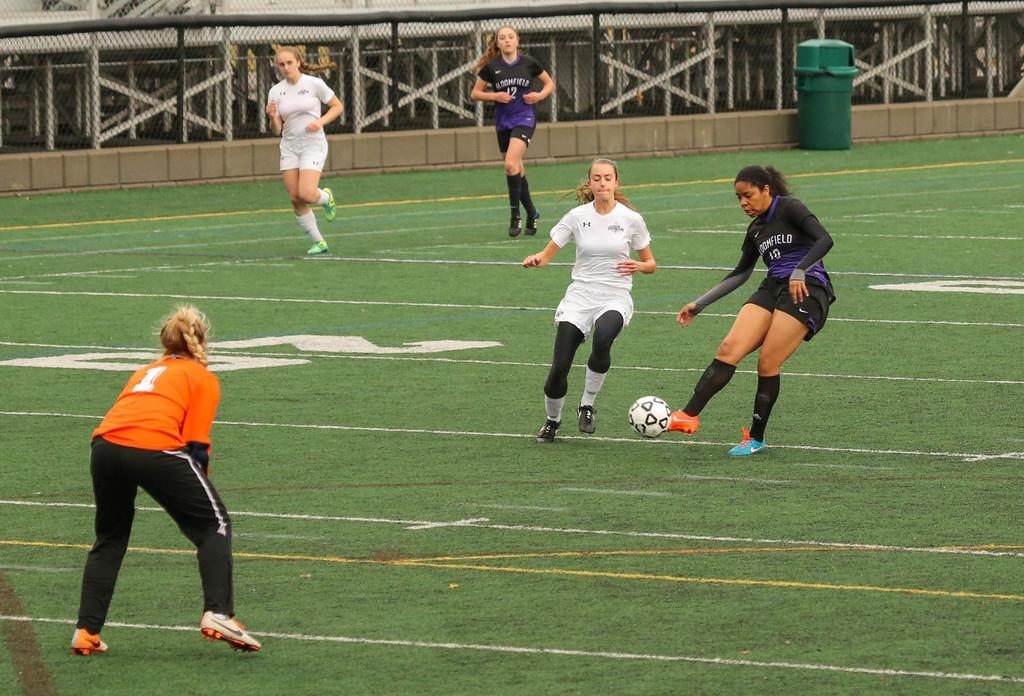In one or two sentences, can you explain what this image depicts? There are five women in the ground playing with a ball. In the background there is a dustbin and a railing here. 